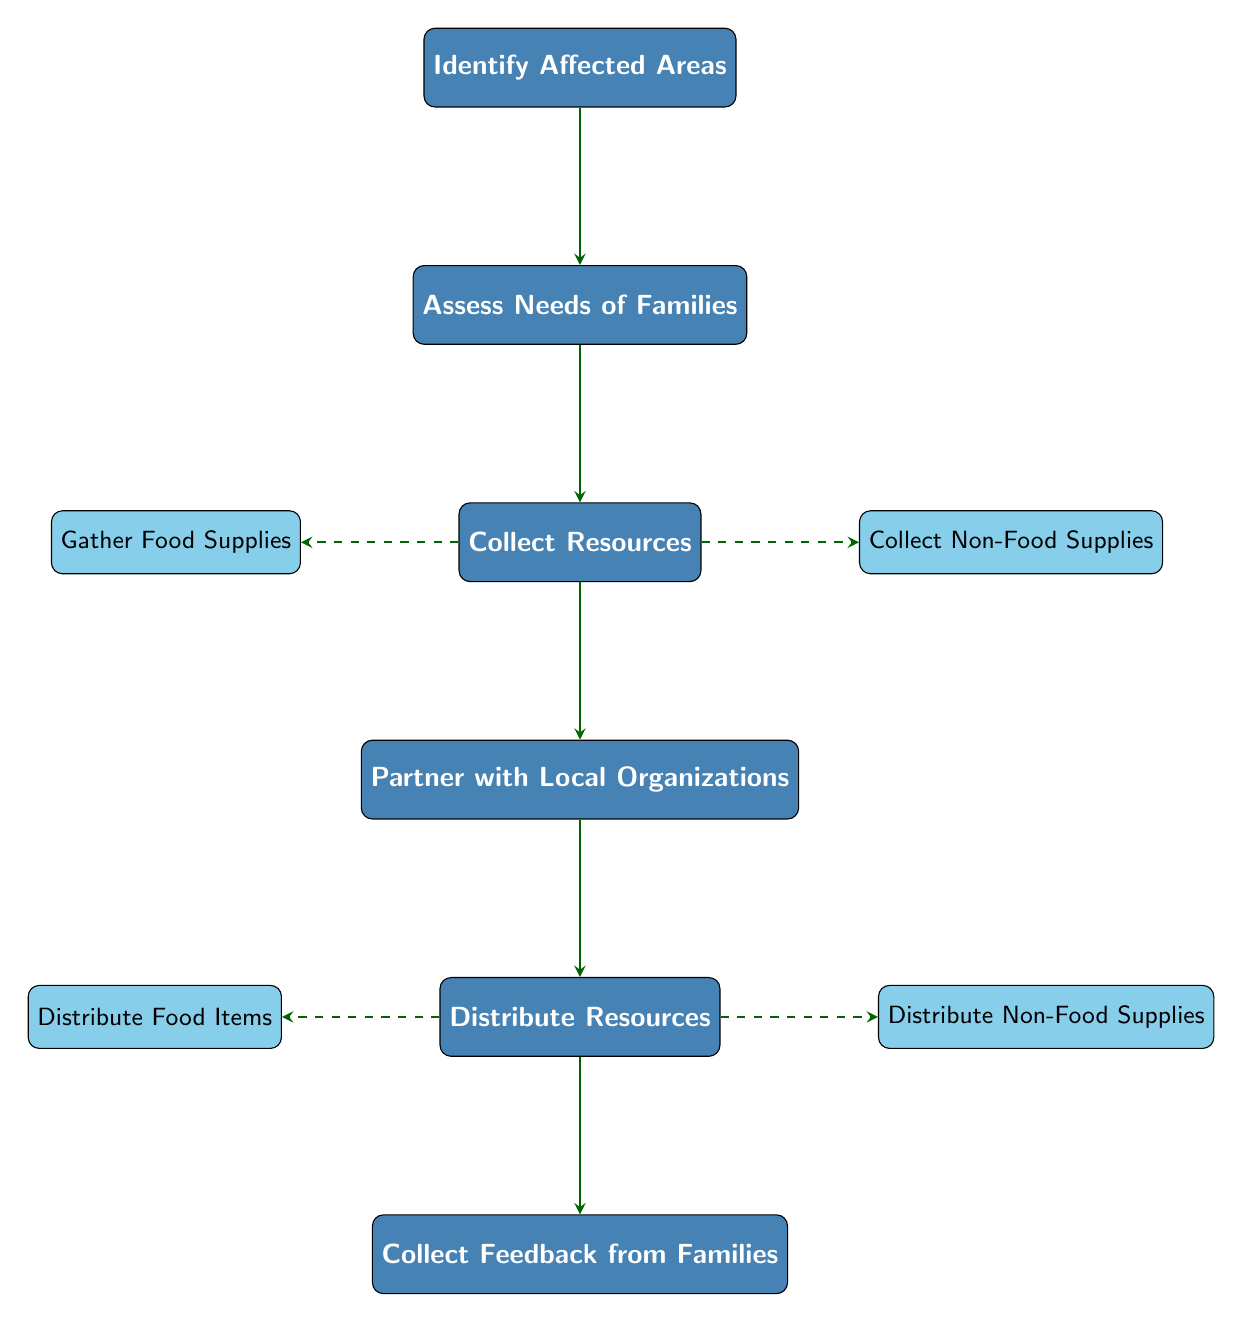What is the first step in the flow chart? The first step listed in the flow chart is "Identify Affected Areas," which is the initial node in the sequence of actions to distribute food and supplies.
Answer: Identify Affected Areas How many main nodes are there in the diagram? The diagram has a total of 6 main nodes: "Identify Affected Areas," "Assess Needs of Families," "Collect Resources," "Partner with Local Organizations," "Distribute Resources," and "Collect Feedback from Families."
Answer: 6 Which node follows "Collect Resources"? The node that follows "Collect Resources" in the flow chart is "Partner with Local Organizations." This is determined by examining the arrows representing the flow of actions.
Answer: Partner with Local Organizations What are the two types of resources collected? The two types of resources collected are "Food Supplies" and "Non-Food Supplies," indicated as subnodes under "Collect Resources."
Answer: Food Supplies, Non-Food Supplies After distributing resources, what is the next step indicated in the flow chart? After "Distribute Resources," the next step indicated is "Collect Feedback from Families," which shows that feedback is gathered after resource distribution.
Answer: Collect Feedback from Families Which node is linked to both "Assess Needs of Families" and "Collect Resources"? The node linked to both "Assess Needs of Families" and "Collect Resources" is "Collect Resources." This shows that the outcome of the needs assessment leads directly to the collection of resources.
Answer: Collect Resources What is the purpose of partnering with local organizations in this diagram? The purpose of partnering with local organizations is to facilitate "Distribute Resources," which indicates that local partnerships are essential for effective distribution.
Answer: Distribute Resources List the subnodes under the "Distribute Resources" node. The subnodes under "Distribute Resources" are "Distribute Food Items" and "Distribute Non-Food Supplies," representing the types of resources being distributed in the process.
Answer: Distribute Food Items, Distribute Non-Food Supplies 